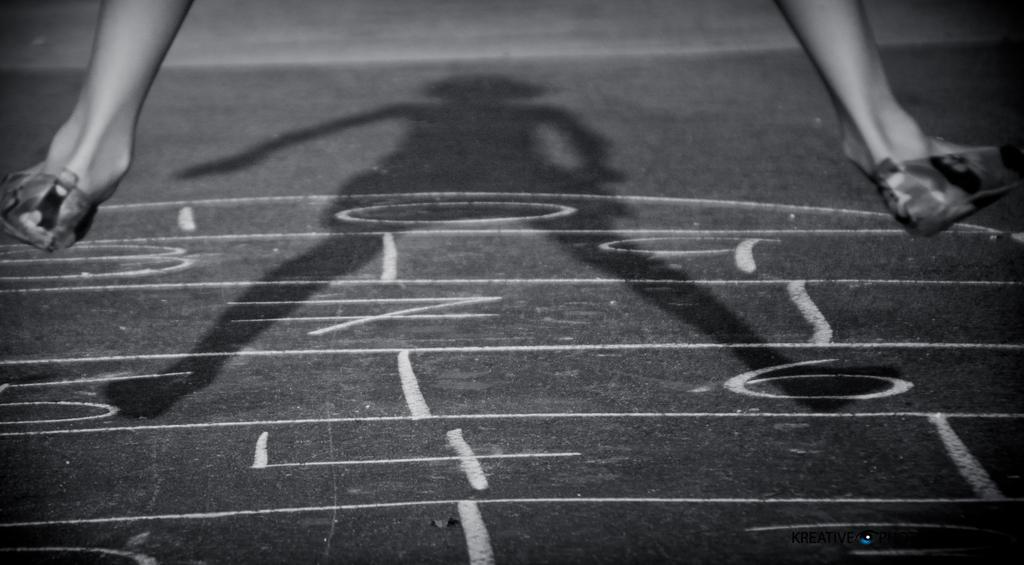What can be found at the bottom of the image? There are numbers at the bottom of the image. What is visible in the middle of the image? There is a shadow in the middle of the image. What part of the human body is present on either side of the image? There are human legs on either side of the image. How many snails can be seen crawling on the human legs in the image? There are no snails present in the image; it only features human legs and a shadow. What type of society is depicted in the image? The image does not depict any society; it only contains numbers, a shadow, and human legs. 